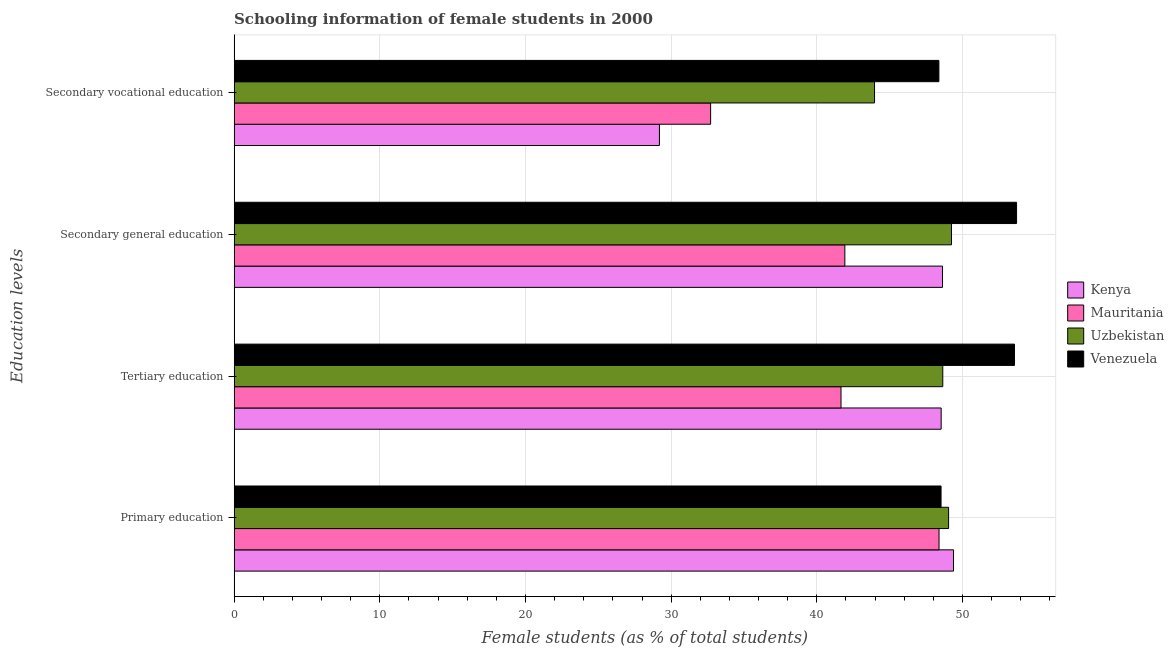Are the number of bars per tick equal to the number of legend labels?
Give a very brief answer. Yes. Are the number of bars on each tick of the Y-axis equal?
Provide a succinct answer. Yes. How many bars are there on the 2nd tick from the bottom?
Offer a terse response. 4. What is the percentage of female students in secondary education in Venezuela?
Your answer should be compact. 53.71. Across all countries, what is the maximum percentage of female students in secondary vocational education?
Keep it short and to the point. 48.38. Across all countries, what is the minimum percentage of female students in secondary vocational education?
Make the answer very short. 29.2. In which country was the percentage of female students in tertiary education maximum?
Give a very brief answer. Venezuela. In which country was the percentage of female students in secondary education minimum?
Ensure brevity in your answer.  Mauritania. What is the total percentage of female students in secondary vocational education in the graph?
Give a very brief answer. 154.25. What is the difference between the percentage of female students in secondary education in Uzbekistan and that in Mauritania?
Offer a terse response. 7.32. What is the difference between the percentage of female students in tertiary education in Kenya and the percentage of female students in secondary vocational education in Uzbekistan?
Offer a terse response. 4.57. What is the average percentage of female students in tertiary education per country?
Offer a very short reply. 48.1. What is the difference between the percentage of female students in secondary education and percentage of female students in secondary vocational education in Mauritania?
Offer a very short reply. 9.21. In how many countries, is the percentage of female students in secondary education greater than 26 %?
Your answer should be compact. 4. What is the ratio of the percentage of female students in secondary education in Uzbekistan to that in Mauritania?
Give a very brief answer. 1.17. Is the percentage of female students in primary education in Venezuela less than that in Uzbekistan?
Your answer should be very brief. Yes. What is the difference between the highest and the second highest percentage of female students in tertiary education?
Provide a succinct answer. 4.92. What is the difference between the highest and the lowest percentage of female students in secondary vocational education?
Offer a terse response. 19.18. In how many countries, is the percentage of female students in tertiary education greater than the average percentage of female students in tertiary education taken over all countries?
Your response must be concise. 3. Is the sum of the percentage of female students in primary education in Mauritania and Kenya greater than the maximum percentage of female students in secondary vocational education across all countries?
Your answer should be compact. Yes. Is it the case that in every country, the sum of the percentage of female students in primary education and percentage of female students in secondary vocational education is greater than the sum of percentage of female students in tertiary education and percentage of female students in secondary education?
Provide a succinct answer. Yes. What does the 1st bar from the top in Primary education represents?
Give a very brief answer. Venezuela. What does the 1st bar from the bottom in Primary education represents?
Make the answer very short. Kenya. Is it the case that in every country, the sum of the percentage of female students in primary education and percentage of female students in tertiary education is greater than the percentage of female students in secondary education?
Offer a very short reply. Yes. How many bars are there?
Your response must be concise. 16. Are all the bars in the graph horizontal?
Your answer should be very brief. Yes. How many countries are there in the graph?
Make the answer very short. 4. What is the difference between two consecutive major ticks on the X-axis?
Your response must be concise. 10. How are the legend labels stacked?
Make the answer very short. Vertical. What is the title of the graph?
Your answer should be compact. Schooling information of female students in 2000. What is the label or title of the X-axis?
Give a very brief answer. Female students (as % of total students). What is the label or title of the Y-axis?
Your answer should be very brief. Education levels. What is the Female students (as % of total students) in Kenya in Primary education?
Ensure brevity in your answer.  49.38. What is the Female students (as % of total students) in Mauritania in Primary education?
Your answer should be compact. 48.39. What is the Female students (as % of total students) in Uzbekistan in Primary education?
Your answer should be very brief. 49.05. What is the Female students (as % of total students) in Venezuela in Primary education?
Ensure brevity in your answer.  48.53. What is the Female students (as % of total students) in Kenya in Tertiary education?
Your answer should be very brief. 48.54. What is the Female students (as % of total students) in Mauritania in Tertiary education?
Keep it short and to the point. 41.66. What is the Female students (as % of total students) of Uzbekistan in Tertiary education?
Your answer should be very brief. 48.65. What is the Female students (as % of total students) of Venezuela in Tertiary education?
Keep it short and to the point. 53.57. What is the Female students (as % of total students) of Kenya in Secondary general education?
Give a very brief answer. 48.63. What is the Female students (as % of total students) of Mauritania in Secondary general education?
Keep it short and to the point. 41.92. What is the Female students (as % of total students) of Uzbekistan in Secondary general education?
Give a very brief answer. 49.24. What is the Female students (as % of total students) in Venezuela in Secondary general education?
Your response must be concise. 53.71. What is the Female students (as % of total students) in Kenya in Secondary vocational education?
Your answer should be compact. 29.2. What is the Female students (as % of total students) of Mauritania in Secondary vocational education?
Ensure brevity in your answer.  32.71. What is the Female students (as % of total students) of Uzbekistan in Secondary vocational education?
Your answer should be very brief. 43.96. What is the Female students (as % of total students) of Venezuela in Secondary vocational education?
Offer a terse response. 48.38. Across all Education levels, what is the maximum Female students (as % of total students) of Kenya?
Your answer should be very brief. 49.38. Across all Education levels, what is the maximum Female students (as % of total students) of Mauritania?
Provide a short and direct response. 48.39. Across all Education levels, what is the maximum Female students (as % of total students) of Uzbekistan?
Your answer should be very brief. 49.24. Across all Education levels, what is the maximum Female students (as % of total students) of Venezuela?
Give a very brief answer. 53.71. Across all Education levels, what is the minimum Female students (as % of total students) of Kenya?
Your answer should be very brief. 29.2. Across all Education levels, what is the minimum Female students (as % of total students) of Mauritania?
Offer a terse response. 32.71. Across all Education levels, what is the minimum Female students (as % of total students) in Uzbekistan?
Your answer should be compact. 43.96. Across all Education levels, what is the minimum Female students (as % of total students) in Venezuela?
Give a very brief answer. 48.38. What is the total Female students (as % of total students) of Kenya in the graph?
Your answer should be very brief. 175.74. What is the total Female students (as % of total students) in Mauritania in the graph?
Your response must be concise. 164.68. What is the total Female students (as % of total students) of Uzbekistan in the graph?
Your answer should be very brief. 190.9. What is the total Female students (as % of total students) in Venezuela in the graph?
Make the answer very short. 204.19. What is the difference between the Female students (as % of total students) of Kenya in Primary education and that in Tertiary education?
Your response must be concise. 0.85. What is the difference between the Female students (as % of total students) of Mauritania in Primary education and that in Tertiary education?
Offer a very short reply. 6.73. What is the difference between the Female students (as % of total students) of Uzbekistan in Primary education and that in Tertiary education?
Offer a terse response. 0.4. What is the difference between the Female students (as % of total students) of Venezuela in Primary education and that in Tertiary education?
Offer a very short reply. -5.04. What is the difference between the Female students (as % of total students) in Kenya in Primary education and that in Secondary general education?
Provide a succinct answer. 0.76. What is the difference between the Female students (as % of total students) in Mauritania in Primary education and that in Secondary general education?
Provide a succinct answer. 6.47. What is the difference between the Female students (as % of total students) in Uzbekistan in Primary education and that in Secondary general education?
Offer a very short reply. -0.2. What is the difference between the Female students (as % of total students) in Venezuela in Primary education and that in Secondary general education?
Make the answer very short. -5.18. What is the difference between the Female students (as % of total students) in Kenya in Primary education and that in Secondary vocational education?
Make the answer very short. 20.19. What is the difference between the Female students (as % of total students) in Mauritania in Primary education and that in Secondary vocational education?
Offer a terse response. 15.68. What is the difference between the Female students (as % of total students) in Uzbekistan in Primary education and that in Secondary vocational education?
Offer a terse response. 5.08. What is the difference between the Female students (as % of total students) in Venezuela in Primary education and that in Secondary vocational education?
Your answer should be very brief. 0.15. What is the difference between the Female students (as % of total students) of Kenya in Tertiary education and that in Secondary general education?
Keep it short and to the point. -0.09. What is the difference between the Female students (as % of total students) in Mauritania in Tertiary education and that in Secondary general education?
Your response must be concise. -0.26. What is the difference between the Female students (as % of total students) in Uzbekistan in Tertiary education and that in Secondary general education?
Make the answer very short. -0.6. What is the difference between the Female students (as % of total students) of Venezuela in Tertiary education and that in Secondary general education?
Ensure brevity in your answer.  -0.14. What is the difference between the Female students (as % of total students) of Kenya in Tertiary education and that in Secondary vocational education?
Give a very brief answer. 19.34. What is the difference between the Female students (as % of total students) in Mauritania in Tertiary education and that in Secondary vocational education?
Keep it short and to the point. 8.95. What is the difference between the Female students (as % of total students) in Uzbekistan in Tertiary education and that in Secondary vocational education?
Provide a succinct answer. 4.68. What is the difference between the Female students (as % of total students) of Venezuela in Tertiary education and that in Secondary vocational education?
Offer a very short reply. 5.19. What is the difference between the Female students (as % of total students) in Kenya in Secondary general education and that in Secondary vocational education?
Provide a short and direct response. 19.43. What is the difference between the Female students (as % of total students) in Mauritania in Secondary general education and that in Secondary vocational education?
Give a very brief answer. 9.21. What is the difference between the Female students (as % of total students) in Uzbekistan in Secondary general education and that in Secondary vocational education?
Provide a succinct answer. 5.28. What is the difference between the Female students (as % of total students) of Venezuela in Secondary general education and that in Secondary vocational education?
Provide a short and direct response. 5.33. What is the difference between the Female students (as % of total students) in Kenya in Primary education and the Female students (as % of total students) in Mauritania in Tertiary education?
Your answer should be compact. 7.72. What is the difference between the Female students (as % of total students) of Kenya in Primary education and the Female students (as % of total students) of Uzbekistan in Tertiary education?
Offer a very short reply. 0.74. What is the difference between the Female students (as % of total students) in Kenya in Primary education and the Female students (as % of total students) in Venezuela in Tertiary education?
Give a very brief answer. -4.19. What is the difference between the Female students (as % of total students) in Mauritania in Primary education and the Female students (as % of total students) in Uzbekistan in Tertiary education?
Your answer should be compact. -0.26. What is the difference between the Female students (as % of total students) of Mauritania in Primary education and the Female students (as % of total students) of Venezuela in Tertiary education?
Provide a short and direct response. -5.18. What is the difference between the Female students (as % of total students) in Uzbekistan in Primary education and the Female students (as % of total students) in Venezuela in Tertiary education?
Give a very brief answer. -4.52. What is the difference between the Female students (as % of total students) in Kenya in Primary education and the Female students (as % of total students) in Mauritania in Secondary general education?
Your response must be concise. 7.46. What is the difference between the Female students (as % of total students) of Kenya in Primary education and the Female students (as % of total students) of Uzbekistan in Secondary general education?
Your response must be concise. 0.14. What is the difference between the Female students (as % of total students) of Kenya in Primary education and the Female students (as % of total students) of Venezuela in Secondary general education?
Your answer should be very brief. -4.33. What is the difference between the Female students (as % of total students) in Mauritania in Primary education and the Female students (as % of total students) in Uzbekistan in Secondary general education?
Ensure brevity in your answer.  -0.85. What is the difference between the Female students (as % of total students) of Mauritania in Primary education and the Female students (as % of total students) of Venezuela in Secondary general education?
Make the answer very short. -5.32. What is the difference between the Female students (as % of total students) of Uzbekistan in Primary education and the Female students (as % of total students) of Venezuela in Secondary general education?
Offer a very short reply. -4.67. What is the difference between the Female students (as % of total students) of Kenya in Primary education and the Female students (as % of total students) of Mauritania in Secondary vocational education?
Make the answer very short. 16.67. What is the difference between the Female students (as % of total students) of Kenya in Primary education and the Female students (as % of total students) of Uzbekistan in Secondary vocational education?
Provide a short and direct response. 5.42. What is the difference between the Female students (as % of total students) of Mauritania in Primary education and the Female students (as % of total students) of Uzbekistan in Secondary vocational education?
Your response must be concise. 4.43. What is the difference between the Female students (as % of total students) in Mauritania in Primary education and the Female students (as % of total students) in Venezuela in Secondary vocational education?
Keep it short and to the point. 0.01. What is the difference between the Female students (as % of total students) in Uzbekistan in Primary education and the Female students (as % of total students) in Venezuela in Secondary vocational education?
Make the answer very short. 0.67. What is the difference between the Female students (as % of total students) in Kenya in Tertiary education and the Female students (as % of total students) in Mauritania in Secondary general education?
Offer a terse response. 6.61. What is the difference between the Female students (as % of total students) of Kenya in Tertiary education and the Female students (as % of total students) of Uzbekistan in Secondary general education?
Your answer should be compact. -0.71. What is the difference between the Female students (as % of total students) of Kenya in Tertiary education and the Female students (as % of total students) of Venezuela in Secondary general education?
Provide a succinct answer. -5.18. What is the difference between the Female students (as % of total students) in Mauritania in Tertiary education and the Female students (as % of total students) in Uzbekistan in Secondary general education?
Your answer should be compact. -7.58. What is the difference between the Female students (as % of total students) in Mauritania in Tertiary education and the Female students (as % of total students) in Venezuela in Secondary general education?
Offer a terse response. -12.05. What is the difference between the Female students (as % of total students) of Uzbekistan in Tertiary education and the Female students (as % of total students) of Venezuela in Secondary general education?
Give a very brief answer. -5.06. What is the difference between the Female students (as % of total students) in Kenya in Tertiary education and the Female students (as % of total students) in Mauritania in Secondary vocational education?
Ensure brevity in your answer.  15.83. What is the difference between the Female students (as % of total students) in Kenya in Tertiary education and the Female students (as % of total students) in Uzbekistan in Secondary vocational education?
Ensure brevity in your answer.  4.57. What is the difference between the Female students (as % of total students) of Kenya in Tertiary education and the Female students (as % of total students) of Venezuela in Secondary vocational education?
Your response must be concise. 0.16. What is the difference between the Female students (as % of total students) in Mauritania in Tertiary education and the Female students (as % of total students) in Uzbekistan in Secondary vocational education?
Your response must be concise. -2.3. What is the difference between the Female students (as % of total students) of Mauritania in Tertiary education and the Female students (as % of total students) of Venezuela in Secondary vocational education?
Your response must be concise. -6.72. What is the difference between the Female students (as % of total students) of Uzbekistan in Tertiary education and the Female students (as % of total students) of Venezuela in Secondary vocational education?
Your answer should be compact. 0.27. What is the difference between the Female students (as % of total students) of Kenya in Secondary general education and the Female students (as % of total students) of Mauritania in Secondary vocational education?
Ensure brevity in your answer.  15.92. What is the difference between the Female students (as % of total students) of Kenya in Secondary general education and the Female students (as % of total students) of Uzbekistan in Secondary vocational education?
Offer a terse response. 4.67. What is the difference between the Female students (as % of total students) of Kenya in Secondary general education and the Female students (as % of total students) of Venezuela in Secondary vocational education?
Ensure brevity in your answer.  0.25. What is the difference between the Female students (as % of total students) of Mauritania in Secondary general education and the Female students (as % of total students) of Uzbekistan in Secondary vocational education?
Your answer should be very brief. -2.04. What is the difference between the Female students (as % of total students) in Mauritania in Secondary general education and the Female students (as % of total students) in Venezuela in Secondary vocational education?
Offer a very short reply. -6.46. What is the difference between the Female students (as % of total students) in Uzbekistan in Secondary general education and the Female students (as % of total students) in Venezuela in Secondary vocational education?
Your response must be concise. 0.86. What is the average Female students (as % of total students) of Kenya per Education levels?
Your response must be concise. 43.94. What is the average Female students (as % of total students) in Mauritania per Education levels?
Your answer should be compact. 41.17. What is the average Female students (as % of total students) of Uzbekistan per Education levels?
Offer a very short reply. 47.72. What is the average Female students (as % of total students) of Venezuela per Education levels?
Your answer should be very brief. 51.05. What is the difference between the Female students (as % of total students) in Kenya and Female students (as % of total students) in Uzbekistan in Primary education?
Provide a short and direct response. 0.34. What is the difference between the Female students (as % of total students) in Kenya and Female students (as % of total students) in Venezuela in Primary education?
Provide a succinct answer. 0.85. What is the difference between the Female students (as % of total students) in Mauritania and Female students (as % of total students) in Uzbekistan in Primary education?
Provide a short and direct response. -0.66. What is the difference between the Female students (as % of total students) in Mauritania and Female students (as % of total students) in Venezuela in Primary education?
Offer a terse response. -0.14. What is the difference between the Female students (as % of total students) in Uzbekistan and Female students (as % of total students) in Venezuela in Primary education?
Provide a short and direct response. 0.52. What is the difference between the Female students (as % of total students) in Kenya and Female students (as % of total students) in Mauritania in Tertiary education?
Ensure brevity in your answer.  6.87. What is the difference between the Female students (as % of total students) in Kenya and Female students (as % of total students) in Uzbekistan in Tertiary education?
Offer a very short reply. -0.11. What is the difference between the Female students (as % of total students) of Kenya and Female students (as % of total students) of Venezuela in Tertiary education?
Offer a very short reply. -5.03. What is the difference between the Female students (as % of total students) of Mauritania and Female students (as % of total students) of Uzbekistan in Tertiary education?
Ensure brevity in your answer.  -6.99. What is the difference between the Female students (as % of total students) of Mauritania and Female students (as % of total students) of Venezuela in Tertiary education?
Provide a short and direct response. -11.91. What is the difference between the Female students (as % of total students) of Uzbekistan and Female students (as % of total students) of Venezuela in Tertiary education?
Keep it short and to the point. -4.92. What is the difference between the Female students (as % of total students) of Kenya and Female students (as % of total students) of Mauritania in Secondary general education?
Your response must be concise. 6.7. What is the difference between the Female students (as % of total students) of Kenya and Female students (as % of total students) of Uzbekistan in Secondary general education?
Offer a terse response. -0.62. What is the difference between the Female students (as % of total students) in Kenya and Female students (as % of total students) in Venezuela in Secondary general education?
Keep it short and to the point. -5.08. What is the difference between the Female students (as % of total students) of Mauritania and Female students (as % of total students) of Uzbekistan in Secondary general education?
Ensure brevity in your answer.  -7.32. What is the difference between the Female students (as % of total students) in Mauritania and Female students (as % of total students) in Venezuela in Secondary general education?
Your answer should be compact. -11.79. What is the difference between the Female students (as % of total students) of Uzbekistan and Female students (as % of total students) of Venezuela in Secondary general education?
Your answer should be compact. -4.47. What is the difference between the Female students (as % of total students) of Kenya and Female students (as % of total students) of Mauritania in Secondary vocational education?
Offer a very short reply. -3.51. What is the difference between the Female students (as % of total students) of Kenya and Female students (as % of total students) of Uzbekistan in Secondary vocational education?
Keep it short and to the point. -14.77. What is the difference between the Female students (as % of total students) in Kenya and Female students (as % of total students) in Venezuela in Secondary vocational education?
Offer a terse response. -19.18. What is the difference between the Female students (as % of total students) in Mauritania and Female students (as % of total students) in Uzbekistan in Secondary vocational education?
Your answer should be compact. -11.25. What is the difference between the Female students (as % of total students) of Mauritania and Female students (as % of total students) of Venezuela in Secondary vocational education?
Ensure brevity in your answer.  -15.67. What is the difference between the Female students (as % of total students) of Uzbekistan and Female students (as % of total students) of Venezuela in Secondary vocational education?
Give a very brief answer. -4.42. What is the ratio of the Female students (as % of total students) in Kenya in Primary education to that in Tertiary education?
Offer a very short reply. 1.02. What is the ratio of the Female students (as % of total students) of Mauritania in Primary education to that in Tertiary education?
Ensure brevity in your answer.  1.16. What is the ratio of the Female students (as % of total students) of Uzbekistan in Primary education to that in Tertiary education?
Your answer should be very brief. 1.01. What is the ratio of the Female students (as % of total students) of Venezuela in Primary education to that in Tertiary education?
Ensure brevity in your answer.  0.91. What is the ratio of the Female students (as % of total students) in Kenya in Primary education to that in Secondary general education?
Your answer should be very brief. 1.02. What is the ratio of the Female students (as % of total students) in Mauritania in Primary education to that in Secondary general education?
Keep it short and to the point. 1.15. What is the ratio of the Female students (as % of total students) in Venezuela in Primary education to that in Secondary general education?
Ensure brevity in your answer.  0.9. What is the ratio of the Female students (as % of total students) of Kenya in Primary education to that in Secondary vocational education?
Your response must be concise. 1.69. What is the ratio of the Female students (as % of total students) in Mauritania in Primary education to that in Secondary vocational education?
Ensure brevity in your answer.  1.48. What is the ratio of the Female students (as % of total students) in Uzbekistan in Primary education to that in Secondary vocational education?
Your answer should be very brief. 1.12. What is the ratio of the Female students (as % of total students) in Venezuela in Primary education to that in Secondary vocational education?
Keep it short and to the point. 1. What is the ratio of the Female students (as % of total students) of Mauritania in Tertiary education to that in Secondary general education?
Give a very brief answer. 0.99. What is the ratio of the Female students (as % of total students) of Uzbekistan in Tertiary education to that in Secondary general education?
Provide a succinct answer. 0.99. What is the ratio of the Female students (as % of total students) of Kenya in Tertiary education to that in Secondary vocational education?
Keep it short and to the point. 1.66. What is the ratio of the Female students (as % of total students) of Mauritania in Tertiary education to that in Secondary vocational education?
Your answer should be compact. 1.27. What is the ratio of the Female students (as % of total students) of Uzbekistan in Tertiary education to that in Secondary vocational education?
Provide a succinct answer. 1.11. What is the ratio of the Female students (as % of total students) of Venezuela in Tertiary education to that in Secondary vocational education?
Your answer should be very brief. 1.11. What is the ratio of the Female students (as % of total students) of Kenya in Secondary general education to that in Secondary vocational education?
Provide a short and direct response. 1.67. What is the ratio of the Female students (as % of total students) of Mauritania in Secondary general education to that in Secondary vocational education?
Your response must be concise. 1.28. What is the ratio of the Female students (as % of total students) in Uzbekistan in Secondary general education to that in Secondary vocational education?
Your answer should be compact. 1.12. What is the ratio of the Female students (as % of total students) of Venezuela in Secondary general education to that in Secondary vocational education?
Make the answer very short. 1.11. What is the difference between the highest and the second highest Female students (as % of total students) in Kenya?
Offer a very short reply. 0.76. What is the difference between the highest and the second highest Female students (as % of total students) of Mauritania?
Offer a very short reply. 6.47. What is the difference between the highest and the second highest Female students (as % of total students) of Uzbekistan?
Ensure brevity in your answer.  0.2. What is the difference between the highest and the second highest Female students (as % of total students) in Venezuela?
Make the answer very short. 0.14. What is the difference between the highest and the lowest Female students (as % of total students) of Kenya?
Make the answer very short. 20.19. What is the difference between the highest and the lowest Female students (as % of total students) of Mauritania?
Offer a very short reply. 15.68. What is the difference between the highest and the lowest Female students (as % of total students) in Uzbekistan?
Provide a short and direct response. 5.28. What is the difference between the highest and the lowest Female students (as % of total students) in Venezuela?
Your answer should be very brief. 5.33. 